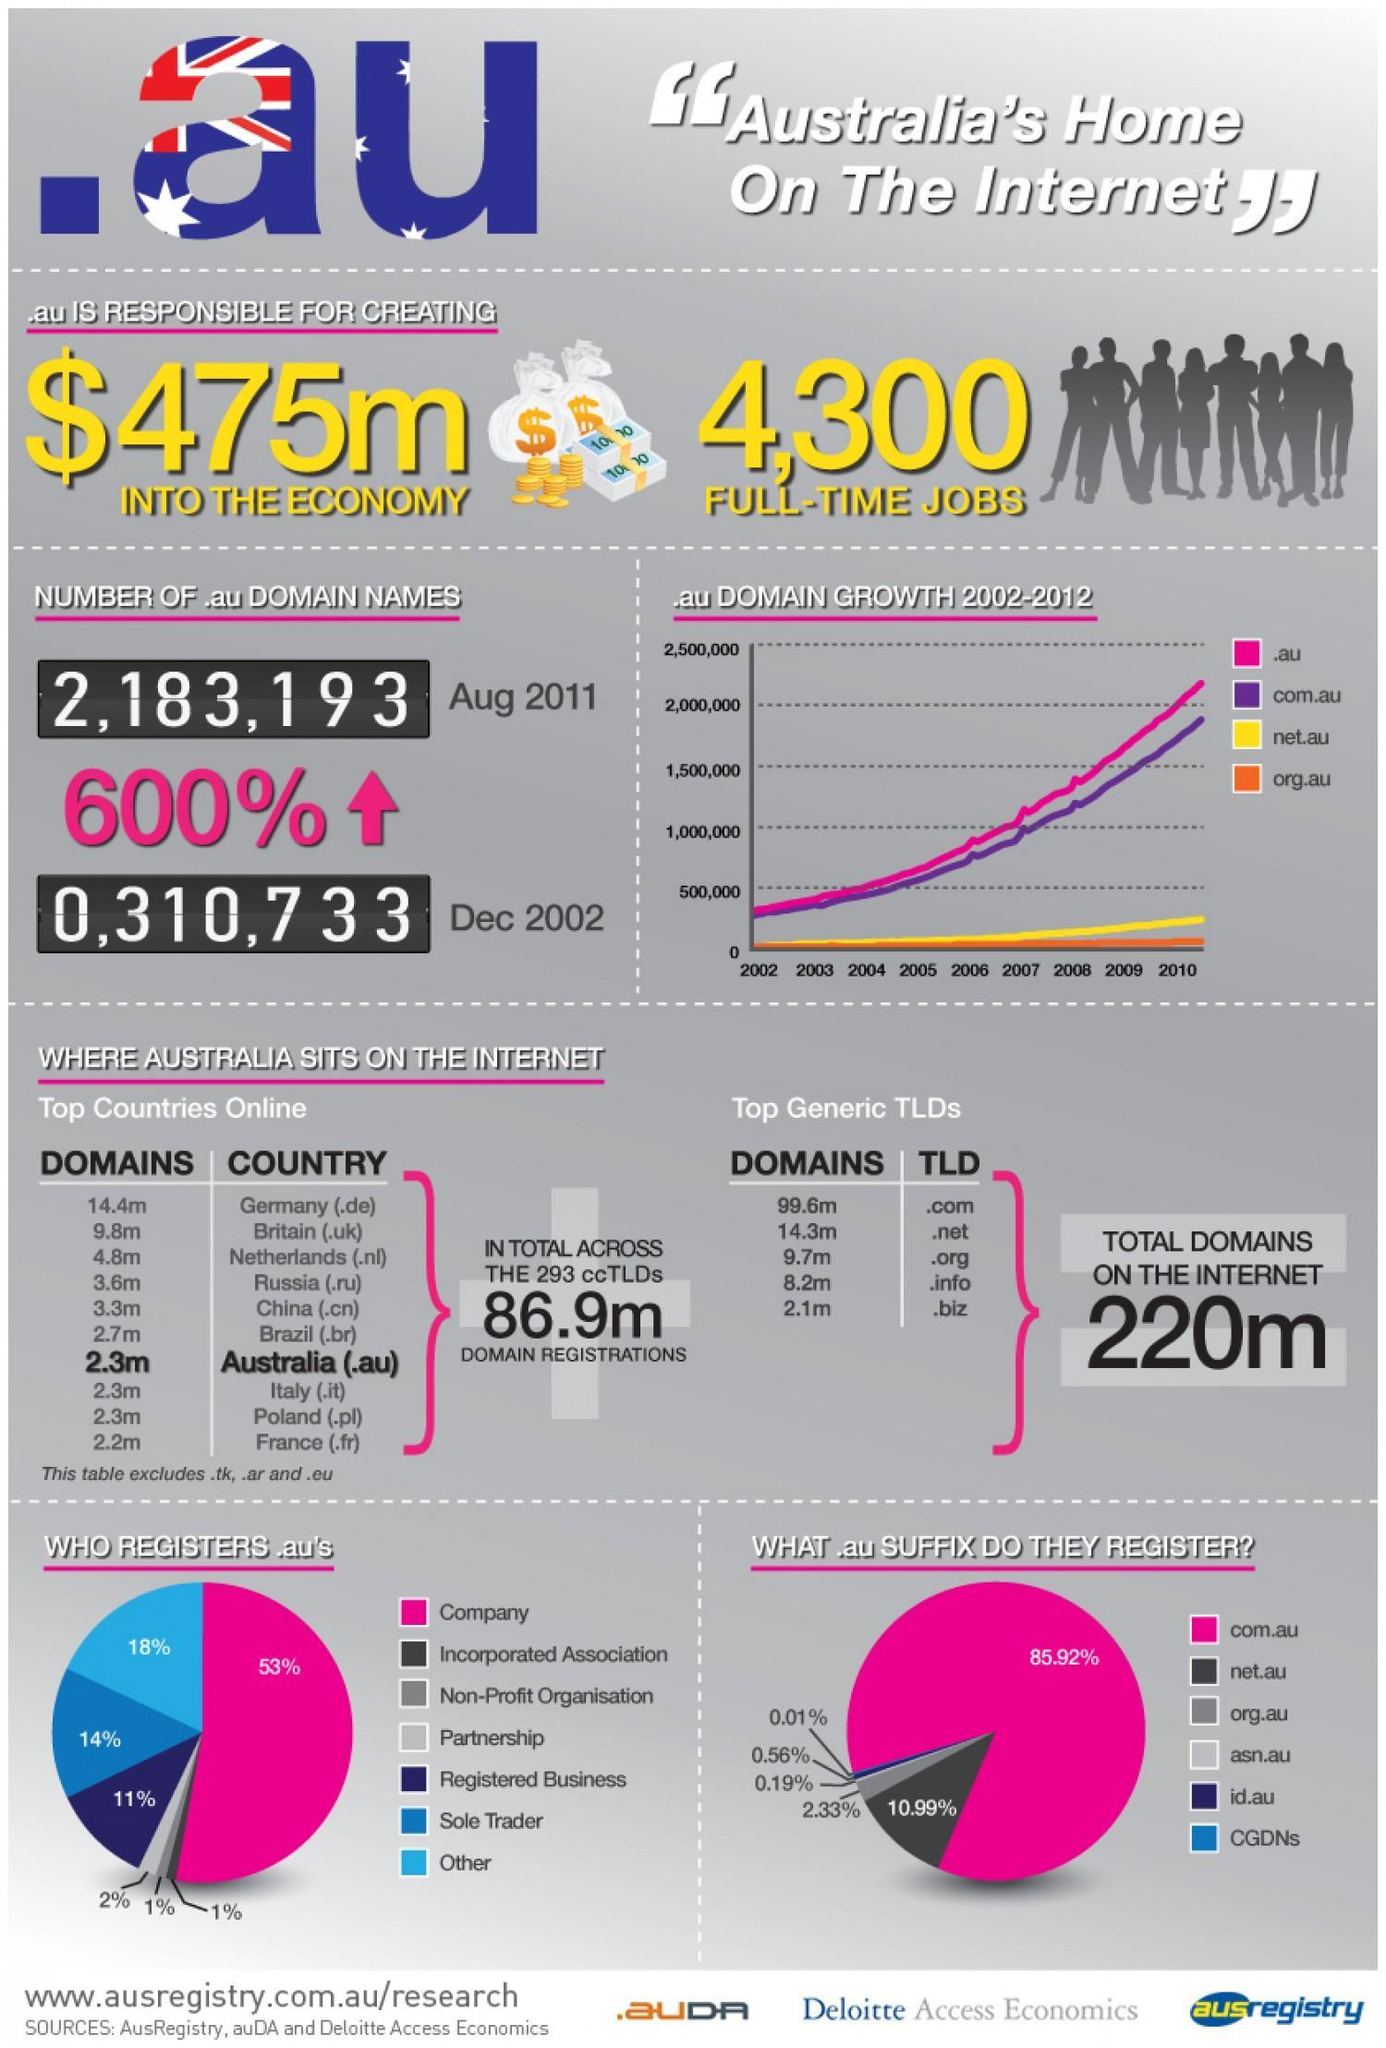what is the percentage of companies and partnership registering for domain .au
Answer the question with a short phrase. 55 Austrialian domains are higher than which country France what is the domain name for australia .au what .au suffix do 10.99% register net.au what has been the increase in .au domain name from 2002 to 2011 600% which domain growth has been second highest com.au 